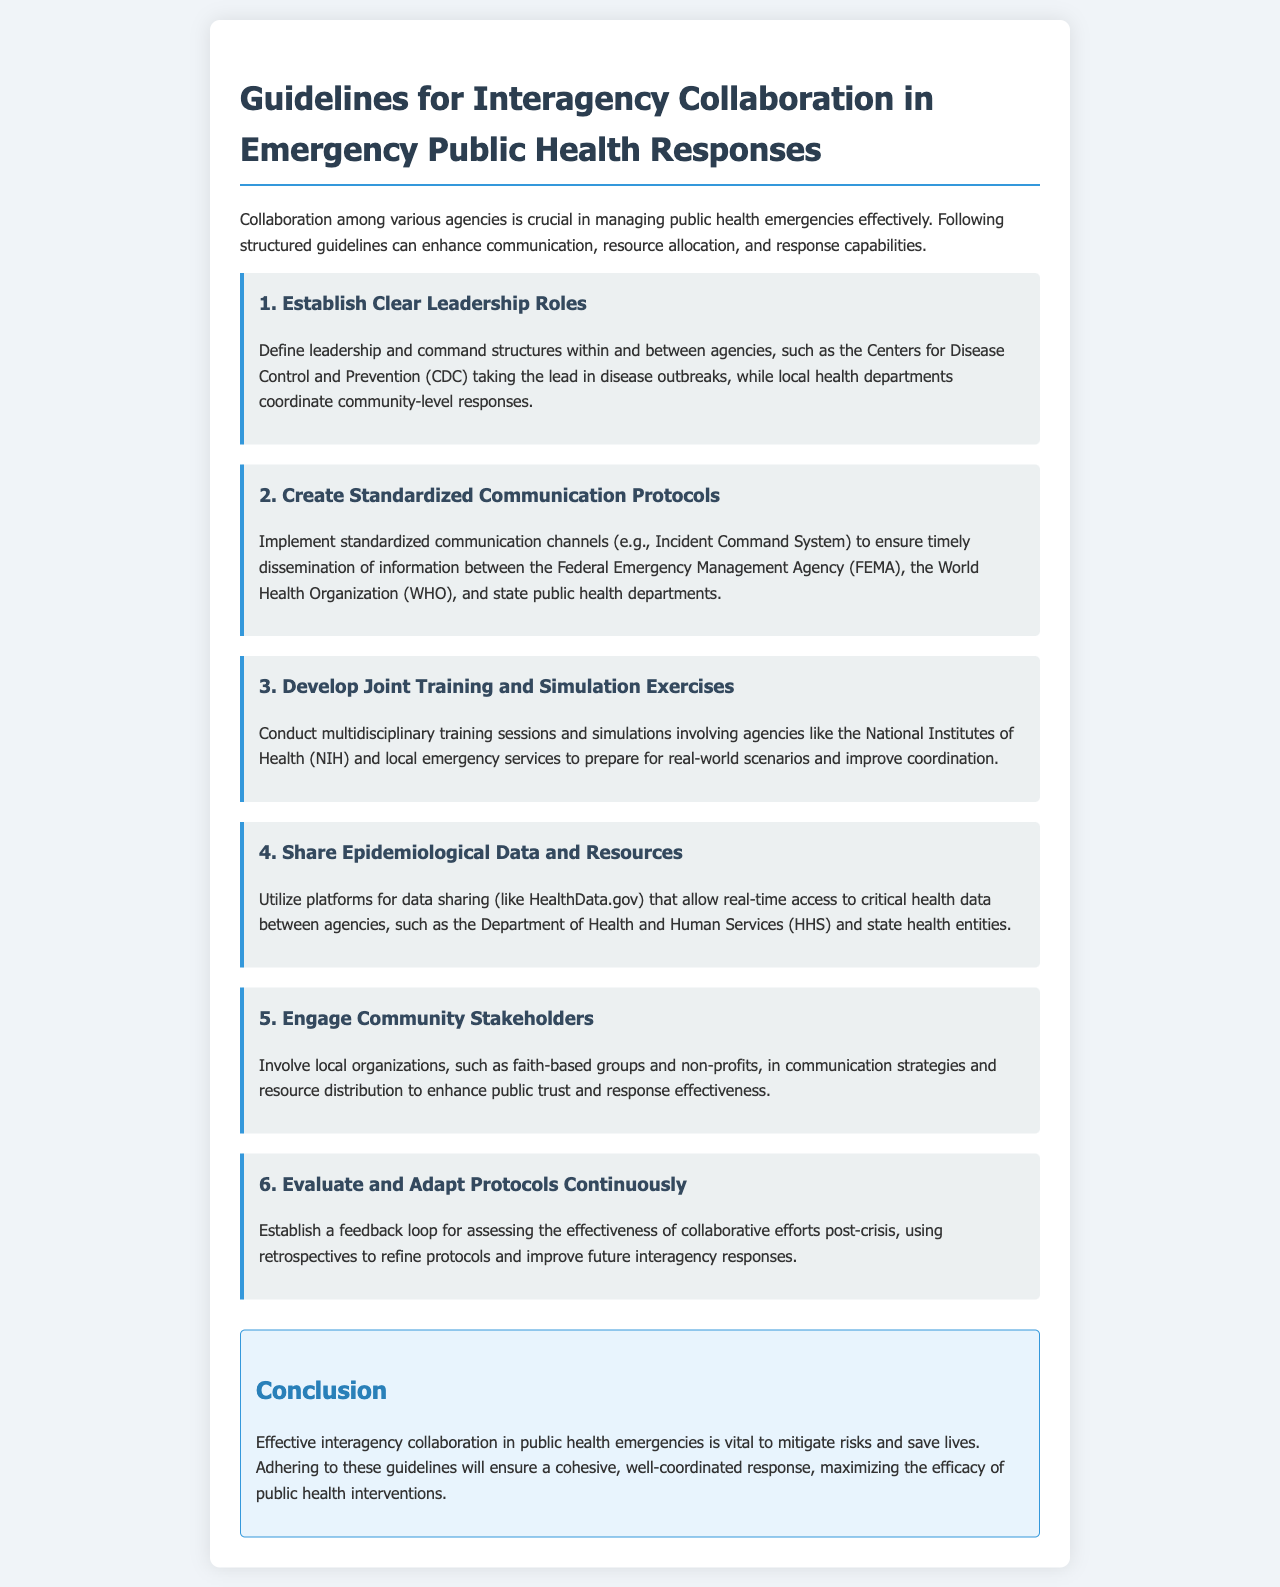What is the first guideline for interagency collaboration? The first guideline is focused on establishing clear leadership roles within and between agencies.
Answer: Establish Clear Leadership Roles Which agency takes the lead in disease outbreaks? The Centers for Disease Control and Prevention (CDC) takes the lead in disease outbreaks as mentioned in the guidelines.
Answer: Centers for Disease Control and Prevention (CDC) What is the main purpose of the standardized communication protocols? The purpose of standardized communication protocols is to ensure timely dissemination of information between various agencies.
Answer: Timely dissemination of information Which agencies are involved in joint training and simulation exercises? The National Institutes of Health (NIH) and local emergency services are involved in these exercises.
Answer: National Institutes of Health (NIH) and local emergency services What type of data is recommended to be shared among agencies? The guidelines recommend sharing epidemiological data and resources among agencies.
Answer: Epidemiological data and resources How should community stakeholders be involved according to the guidelines? Community stakeholders should be involved in communication strategies and resource distribution.
Answer: Communication strategies and resource distribution What is the concluding statement regarding interagency collaboration? The concluding statement emphasizes that effective interagency collaboration is vital to mitigate risks and save lives.
Answer: Vital to mitigate risks and save lives How should protocols be evaluated according to the document? Protocols should be continuously evaluated and adapted through a feedback loop.
Answer: Continuously evaluated and adapted What platform is mentioned for sharing critical health data? HealthData.gov is mentioned as a platform for sharing critical health data among agencies.
Answer: HealthData.gov 